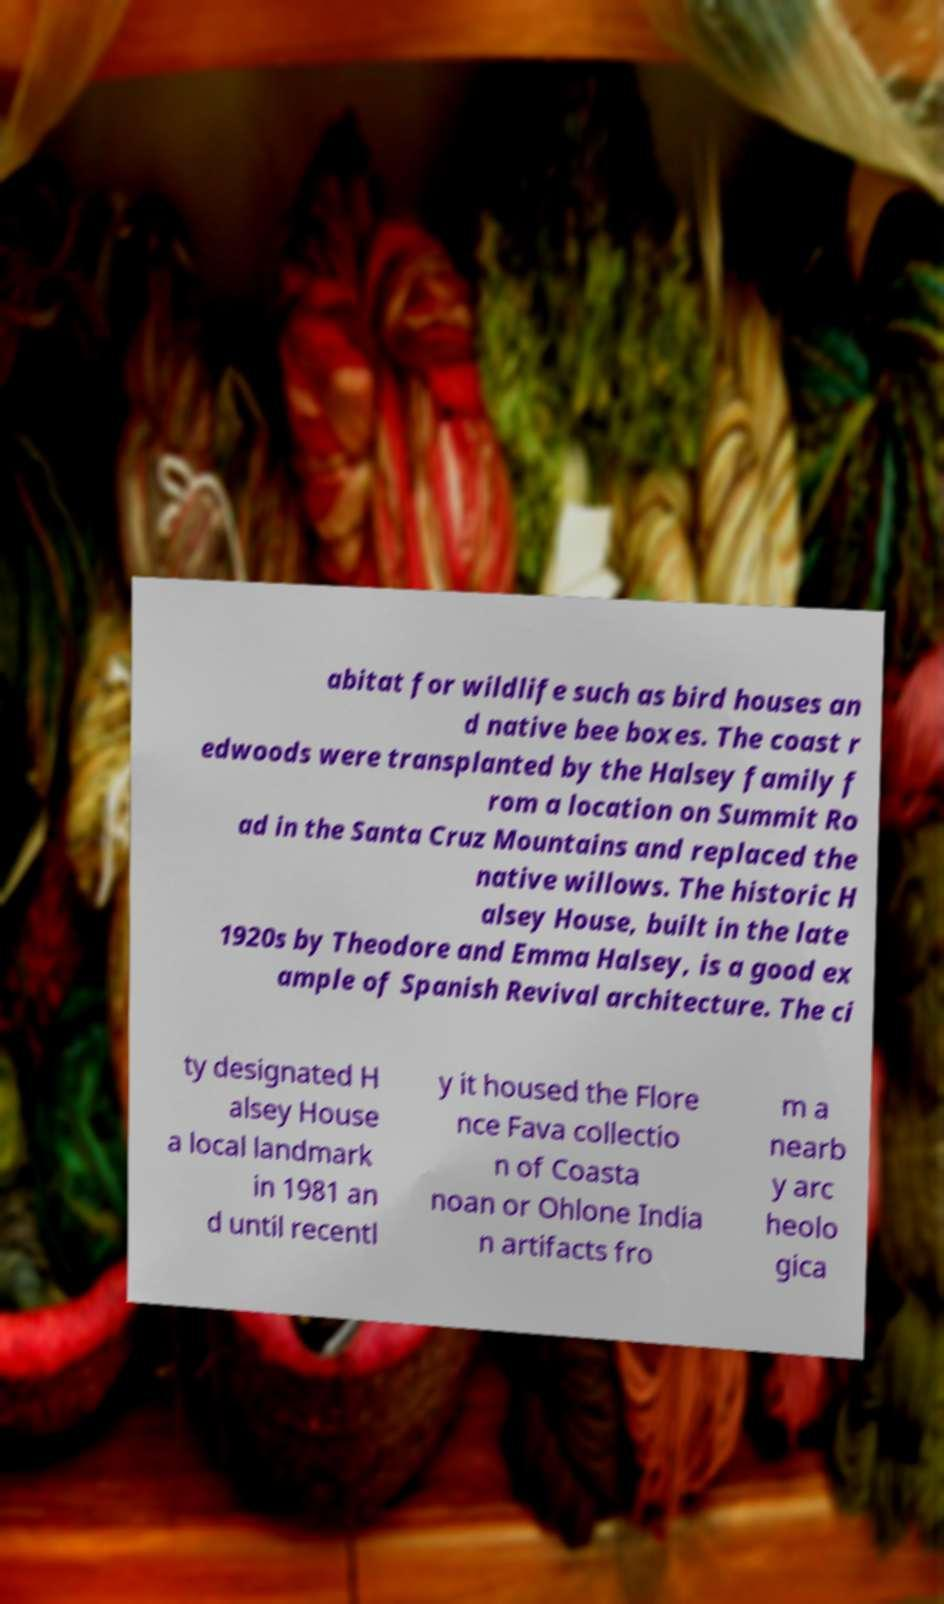I need the written content from this picture converted into text. Can you do that? abitat for wildlife such as bird houses an d native bee boxes. The coast r edwoods were transplanted by the Halsey family f rom a location on Summit Ro ad in the Santa Cruz Mountains and replaced the native willows. The historic H alsey House, built in the late 1920s by Theodore and Emma Halsey, is a good ex ample of Spanish Revival architecture. The ci ty designated H alsey House a local landmark in 1981 an d until recentl y it housed the Flore nce Fava collectio n of Coasta noan or Ohlone India n artifacts fro m a nearb y arc heolo gica 